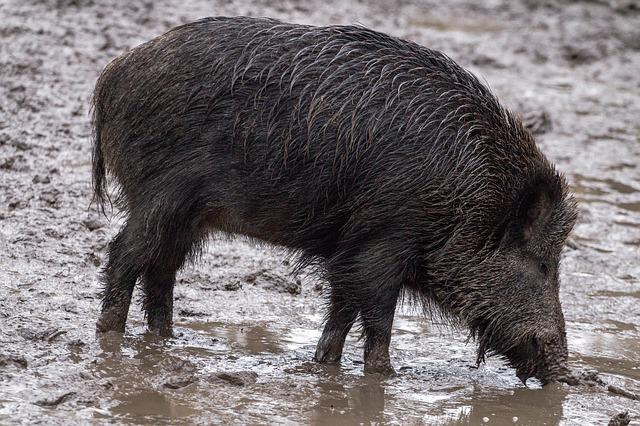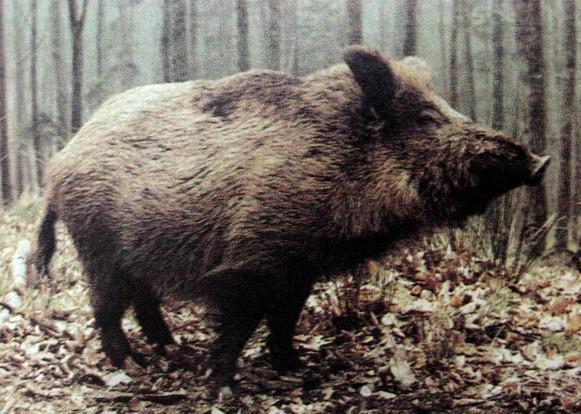The first image is the image on the left, the second image is the image on the right. Evaluate the accuracy of this statement regarding the images: "A boar is facing forward in one image and to the right in the other.". Is it true? Answer yes or no. No. The first image is the image on the left, the second image is the image on the right. Assess this claim about the two images: "The pig in the left image is not alone.". Correct or not? Answer yes or no. No. 